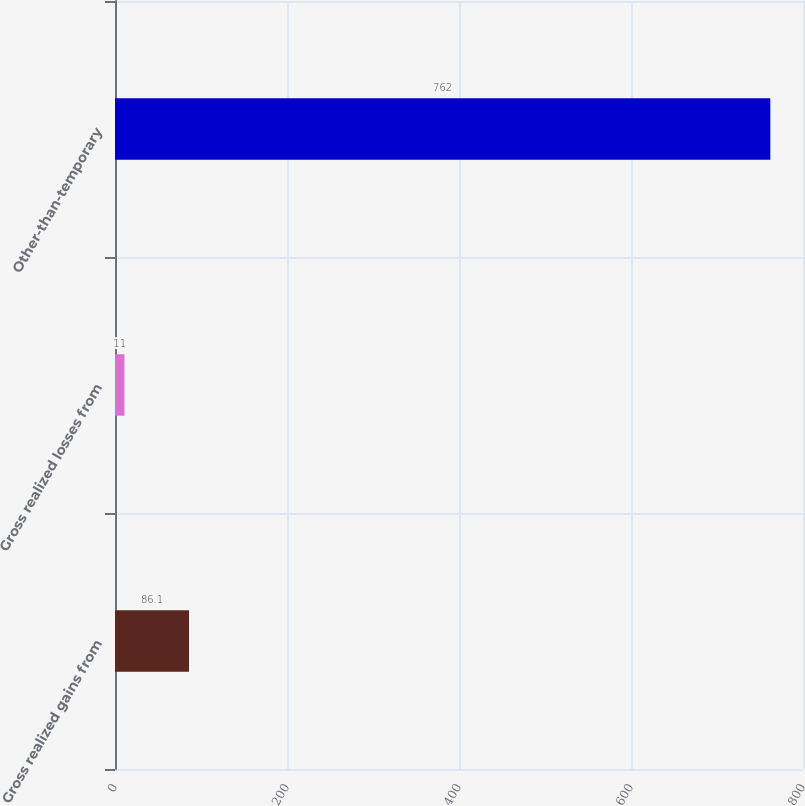Convert chart. <chart><loc_0><loc_0><loc_500><loc_500><bar_chart><fcel>Gross realized gains from<fcel>Gross realized losses from<fcel>Other-than-temporary<nl><fcel>86.1<fcel>11<fcel>762<nl></chart> 